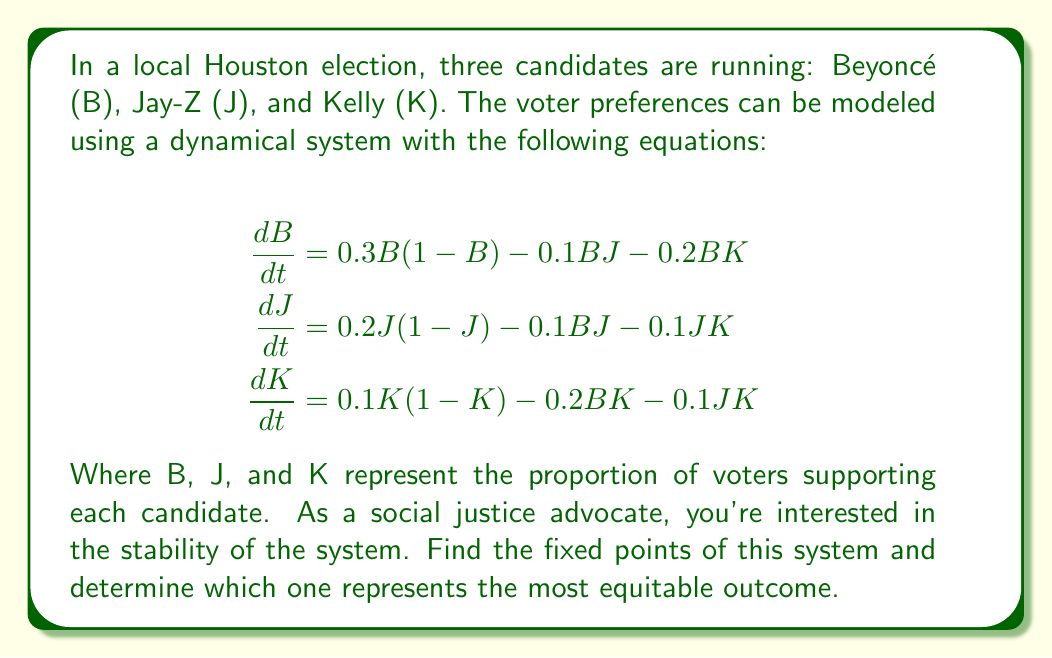Teach me how to tackle this problem. To solve this problem, we'll follow these steps:

1) Find the fixed points by setting each equation to zero and solving for B, J, and K.

2) Evaluate the equity of each fixed point.

Step 1: Finding fixed points

Set each equation to zero:

$$\begin{align}
0 &= 0.3B(1-B) - 0.1BJ - 0.2BK \\
0 &= 0.2J(1-J) - 0.1BJ - 0.1JK \\
0 &= 0.1K(1-K) - 0.2BK - 0.1JK
\end{align}$$

One obvious solution is (0,0,0), but this isn't relevant for our election.

Another solution is when one candidate has all the votes: (1,0,0), (0,1,0), or (0,0,1).

For a more equitable solution, we can solve:

$$\begin{align}
0.3(1-B) - 0.1J - 0.2K &= 0 \\
0.2(1-J) - 0.1B - 0.1K &= 0 \\
0.1(1-K) - 0.2B - 0.1J &= 0
\end{align}$$

Solving this system numerically (as it's complex to solve analytically), we get approximately:

$B \approx 0.4737, J \approx 0.3158, K \approx 0.2105$

Step 2: Evaluating equity

The fixed points we found are:
(1,0,0), (0,1,0), (0,0,1), and (0.4737, 0.3158, 0.2105)

The first three represent complete dominance by one candidate, which isn't equitable. The last fixed point represents a more balanced distribution of voter support, with Beyoncé leading but not dominating.

As a social justice advocate, you would likely consider the last fixed point (0.4737, 0.3158, 0.2105) to be the most equitable, as it allows for representation of all candidates while still reflecting some differences in popularity.
Answer: (0.4737, 0.3158, 0.2105) 